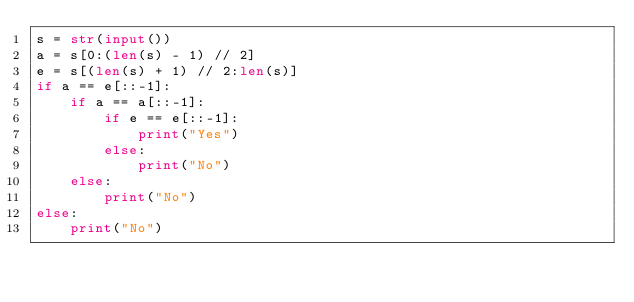<code> <loc_0><loc_0><loc_500><loc_500><_Python_>s = str(input())
a = s[0:(len(s) - 1) // 2]
e = s[(len(s) + 1) // 2:len(s)]
if a == e[::-1]:
    if a == a[::-1]:
        if e == e[::-1]:
            print("Yes")
        else:
            print("No")
    else:
        print("No")
else:
    print("No")</code> 